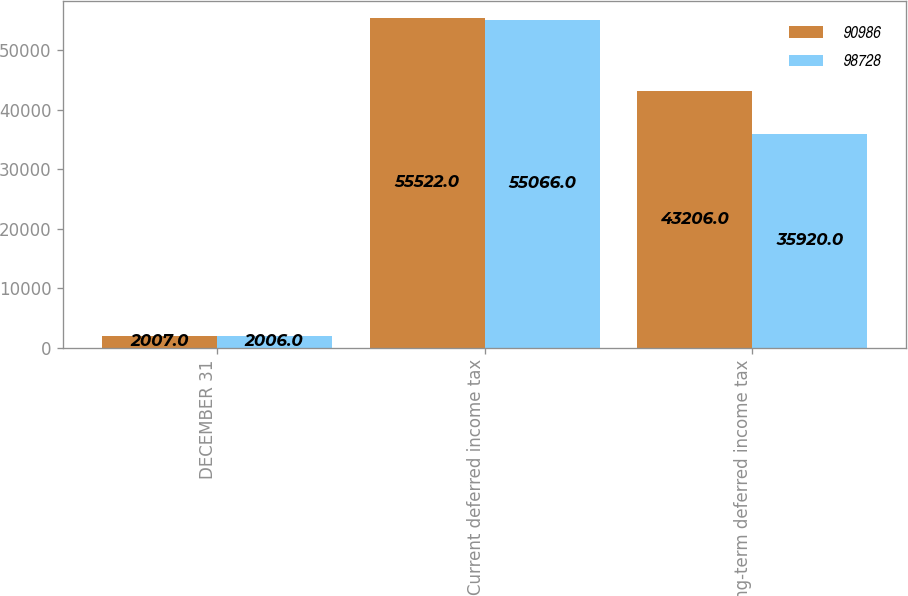<chart> <loc_0><loc_0><loc_500><loc_500><stacked_bar_chart><ecel><fcel>DECEMBER 31<fcel>Current deferred income tax<fcel>Long-term deferred income tax<nl><fcel>90986<fcel>2007<fcel>55522<fcel>43206<nl><fcel>98728<fcel>2006<fcel>55066<fcel>35920<nl></chart> 